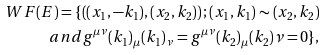<formula> <loc_0><loc_0><loc_500><loc_500>W F ( E ) = \{ \left ( ( x _ { 1 } , - k _ { 1 } ) , ( x _ { 2 } , k _ { 2 } ) \right ) ; ( x _ { 1 } , k _ { 1 } ) \sim ( x _ { 2 } , k _ { 2 } ) \\ a n d g ^ { \mu \nu } ( k _ { 1 } ) _ { \mu } ( k _ { 1 } ) _ { \nu } = g ^ { \mu \nu } ( k _ { 2 } ) _ { \mu } ( k _ { 2 } ) { \nu } = 0 \} ,</formula> 